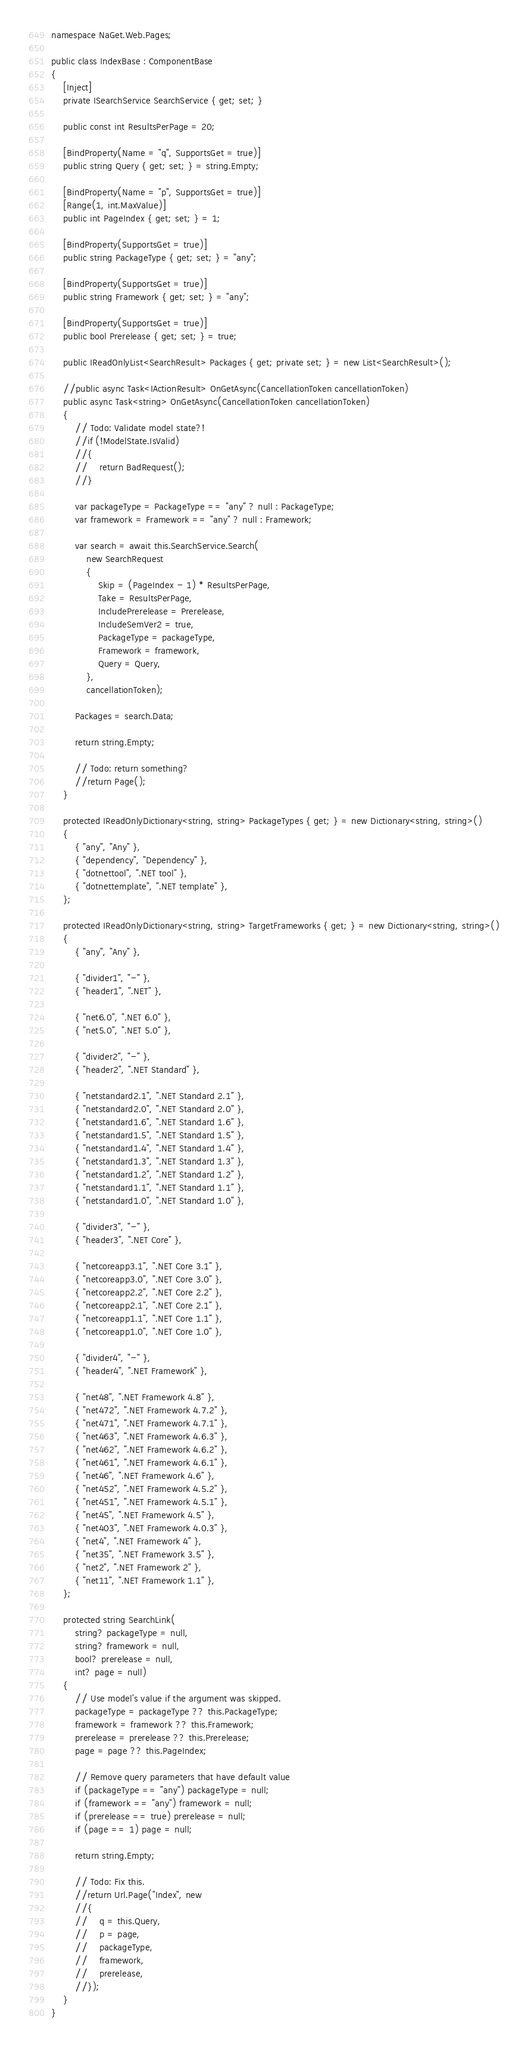<code> <loc_0><loc_0><loc_500><loc_500><_C#_>namespace NaGet.Web.Pages;

public class IndexBase : ComponentBase
{
    [Inject]
    private ISearchService SearchService { get; set; }

    public const int ResultsPerPage = 20;

    [BindProperty(Name = "q", SupportsGet = true)]
    public string Query { get; set; } = string.Empty;

    [BindProperty(Name = "p", SupportsGet = true)]
    [Range(1, int.MaxValue)]
    public int PageIndex { get; set; } = 1;

    [BindProperty(SupportsGet = true)]
    public string PackageType { get; set; } = "any";

    [BindProperty(SupportsGet = true)]
    public string Framework { get; set; } = "any";

    [BindProperty(SupportsGet = true)]
    public bool Prerelease { get; set; } = true;

    public IReadOnlyList<SearchResult> Packages { get; private set; } = new List<SearchResult>();

    //public async Task<IActionResult> OnGetAsync(CancellationToken cancellationToken)
    public async Task<string> OnGetAsync(CancellationToken cancellationToken)
    {
        // Todo: Validate model state?!
        //if (!ModelState.IsValid)
        //{
        //    return BadRequest();
        //}

        var packageType = PackageType == "any" ? null : PackageType;
        var framework = Framework == "any" ? null : Framework;

        var search = await this.SearchService.Search(
            new SearchRequest
            {
                Skip = (PageIndex - 1) * ResultsPerPage,
                Take = ResultsPerPage,
                IncludePrerelease = Prerelease,
                IncludeSemVer2 = true,
                PackageType = packageType,
                Framework = framework,
                Query = Query,
            },
            cancellationToken);

        Packages = search.Data;

        return string.Empty;

        // Todo: return something?
        //return Page();
    }

    protected IReadOnlyDictionary<string, string> PackageTypes { get; } = new Dictionary<string, string>()
    {
        { "any", "Any" },
        { "dependency", "Dependency" },
        { "dotnettool", ".NET tool" },
        { "dotnettemplate", ".NET template" },
    };

    protected IReadOnlyDictionary<string, string> TargetFrameworks { get; } = new Dictionary<string, string>()
    {
        { "any", "Any" },

        { "divider1", "-" },
        { "header1", ".NET" },

        { "net6.0", ".NET 6.0" },
        { "net5.0", ".NET 5.0" },

        { "divider2", "-" },
        { "header2", ".NET Standard" },

        { "netstandard2.1", ".NET Standard 2.1" },
        { "netstandard2.0", ".NET Standard 2.0" },
        { "netstandard1.6", ".NET Standard 1.6" },
        { "netstandard1.5", ".NET Standard 1.5" },
        { "netstandard1.4", ".NET Standard 1.4" },
        { "netstandard1.3", ".NET Standard 1.3" },
        { "netstandard1.2", ".NET Standard 1.2" },
        { "netstandard1.1", ".NET Standard 1.1" },
        { "netstandard1.0", ".NET Standard 1.0" },

        { "divider3", "-" },
        { "header3", ".NET Core" },

        { "netcoreapp3.1", ".NET Core 3.1" },
        { "netcoreapp3.0", ".NET Core 3.0" },
        { "netcoreapp2.2", ".NET Core 2.2" },
        { "netcoreapp2.1", ".NET Core 2.1" },
        { "netcoreapp1.1", ".NET Core 1.1" },
        { "netcoreapp1.0", ".NET Core 1.0" },

        { "divider4", "-" },
        { "header4", ".NET Framework" },

        { "net48", ".NET Framework 4.8" },
        { "net472", ".NET Framework 4.7.2" },
        { "net471", ".NET Framework 4.7.1" },
        { "net463", ".NET Framework 4.6.3" },
        { "net462", ".NET Framework 4.6.2" },
        { "net461", ".NET Framework 4.6.1" },
        { "net46", ".NET Framework 4.6" },
        { "net452", ".NET Framework 4.5.2" },
        { "net451", ".NET Framework 4.5.1" },
        { "net45", ".NET Framework 4.5" },
        { "net403", ".NET Framework 4.0.3" },
        { "net4", ".NET Framework 4" },
        { "net35", ".NET Framework 3.5" },
        { "net2", ".NET Framework 2" },
        { "net11", ".NET Framework 1.1" },
    };

    protected string SearchLink(
        string? packageType = null,
        string? framework = null,
        bool? prerelease = null,
        int? page = null)
    {
        // Use model's value if the argument was skipped.
        packageType = packageType ?? this.PackageType;
        framework = framework ?? this.Framework;
        prerelease = prerelease ?? this.Prerelease;
        page = page ?? this.PageIndex;

        // Remove query parameters that have default value
        if (packageType == "any") packageType = null;
        if (framework == "any") framework = null;
        if (prerelease == true) prerelease = null;
        if (page == 1) page = null;

        return string.Empty;

        // Todo: Fix this.
        //return Url.Page("Index", new
        //{
        //    q = this.Query,
        //    p = page,
        //    packageType,
        //    framework,
        //    prerelease,
        //});
    }
}
</code> 